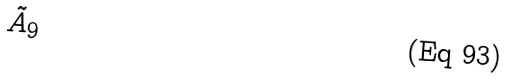Convert formula to latex. <formula><loc_0><loc_0><loc_500><loc_500>\tilde { A } _ { 9 }</formula> 